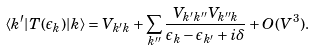Convert formula to latex. <formula><loc_0><loc_0><loc_500><loc_500>\langle k ^ { \prime } | T ( \epsilon _ { k } ) | k \rangle = V _ { k ^ { \prime } k } + \sum _ { k ^ { \prime \prime } } \frac { V _ { k ^ { \prime } k ^ { \prime \prime } } V _ { k ^ { \prime \prime } k } } { \epsilon _ { k } - \epsilon _ { k ^ { \prime } } + i \delta } + O ( V ^ { 3 } ) .</formula> 